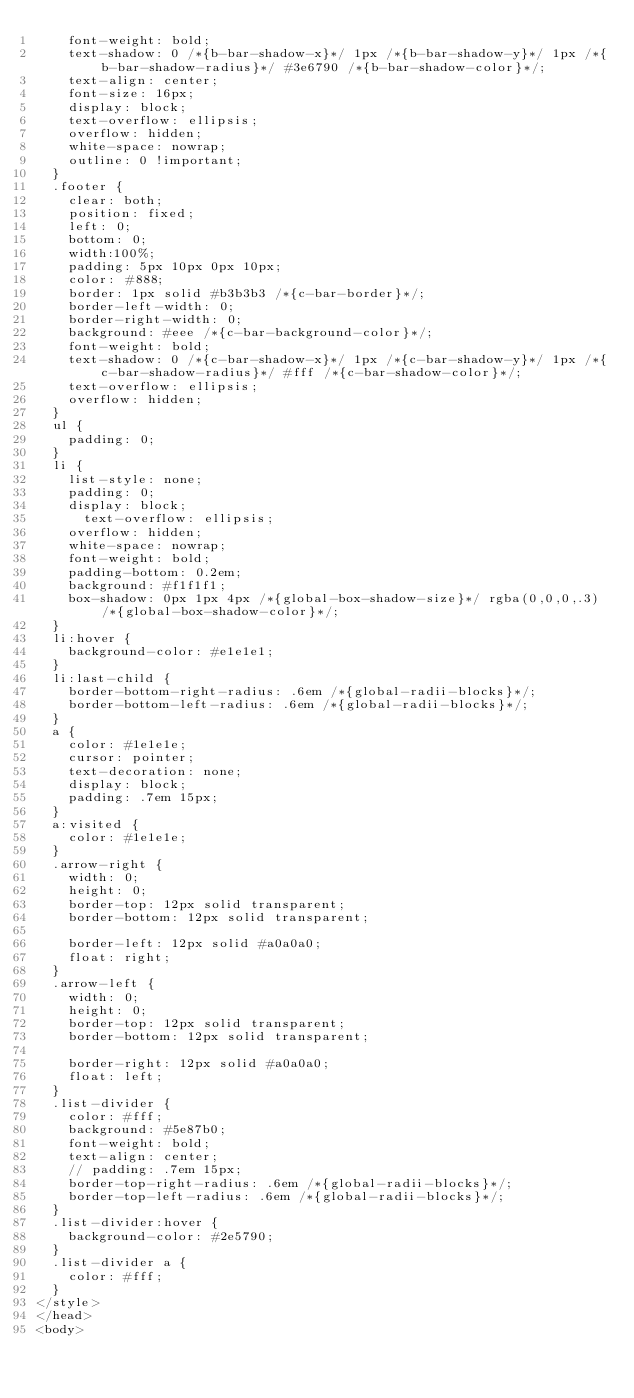Convert code to text. <code><loc_0><loc_0><loc_500><loc_500><_HTML_>		font-weight: bold;
		text-shadow: 0 /*{b-bar-shadow-x}*/ 1px /*{b-bar-shadow-y}*/ 1px /*{b-bar-shadow-radius}*/ #3e6790 /*{b-bar-shadow-color}*/;
		text-align: center;
		font-size: 16px;
		display: block;
		text-overflow: ellipsis;
		overflow: hidden;
		white-space: nowrap;
		outline: 0 !important;
	}
	.footer {
		clear: both;
		position: fixed;
		left: 0;
		bottom: 0;
		width:100%;
		padding: 5px 10px 0px 10px;
		color: #888;
		border: 1px solid #b3b3b3 /*{c-bar-border}*/;
		border-left-width: 0;
		border-right-width: 0;
		background: #eee /*{c-bar-background-color}*/;
		font-weight: bold;
		text-shadow: 0 /*{c-bar-shadow-x}*/ 1px /*{c-bar-shadow-y}*/ 1px /*{c-bar-shadow-radius}*/ #fff /*{c-bar-shadow-color}*/;
		text-overflow: ellipsis;
		overflow: hidden;
	}
	ul {
		padding: 0;
	}
	li {
		list-style: none;
		padding: 0;
		display: block;
	    text-overflow: ellipsis;
		overflow: hidden;
		white-space: nowrap;
		font-weight: bold;
		padding-bottom: 0.2em;
		background: #f1f1f1;
		box-shadow: 0px 1px 4px /*{global-box-shadow-size}*/ rgba(0,0,0,.3) /*{global-box-shadow-color}*/;
	}
	li:hover {
		background-color: #e1e1e1;
	}
	li:last-child {
		border-bottom-right-radius: .6em /*{global-radii-blocks}*/;
		border-bottom-left-radius: .6em /*{global-radii-blocks}*/;
	}
	a {
		color: #1e1e1e;
		cursor: pointer;
		text-decoration: none;
		display: block;
		padding: .7em 15px;
	}
	a:visited {
		color: #1e1e1e;
	}
	.arrow-right {
	  width: 0; 
	  height: 0; 
	  border-top: 12px solid transparent;
	  border-bottom: 12px solid transparent;
	  
	  border-left: 12px solid #a0a0a0;
	  float: right;
	}
	.arrow-left {
	  width: 0; 
	  height: 0; 
	  border-top: 12px solid transparent;
	  border-bottom: 12px solid transparent;
	  
	  border-right: 12px solid #a0a0a0;
	  float: left;
	}
	.list-divider {
		color: #fff;
		background: #5e87b0;
		font-weight: bold;
		text-align: center;
		// padding: .7em 15px;
		border-top-right-radius: .6em /*{global-radii-blocks}*/;
		border-top-left-radius: .6em /*{global-radii-blocks}*/;
	}
	.list-divider:hover {
		background-color: #2e5790;
	}
	.list-divider a {
		color: #fff;
	}
</style>
</head>
<body></code> 